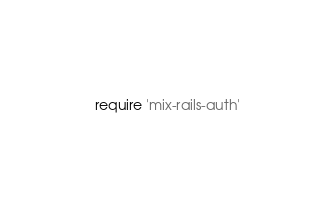<code> <loc_0><loc_0><loc_500><loc_500><_Ruby_>require 'mix-rails-auth'</code> 